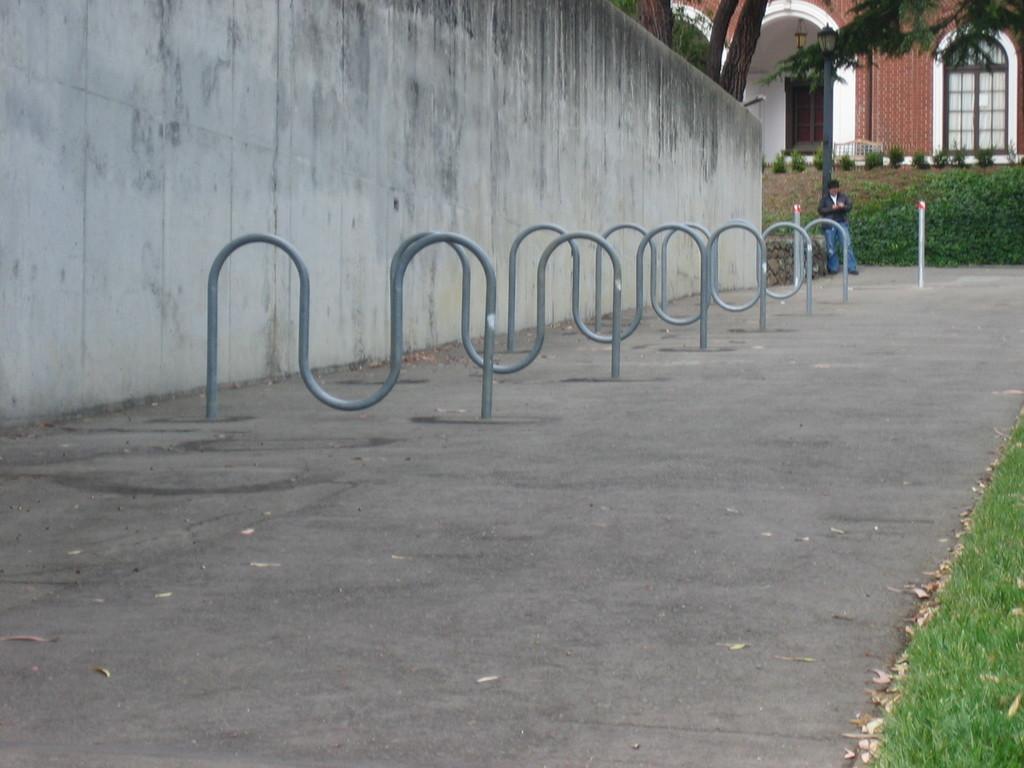Describe this image in one or two sentences. This picture is clicked outside. On the left we can see the metal rods and a wall. In the background we can see the plants, green grass and a person standing on the ground and we can see the tree and the doors of the building. 